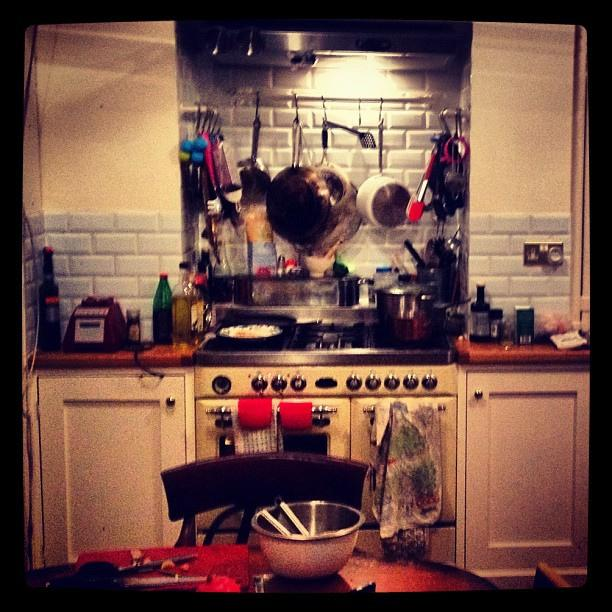What items are found on the wall? Please explain your reasoning. pots. Pots of various sizes are on the wall. 